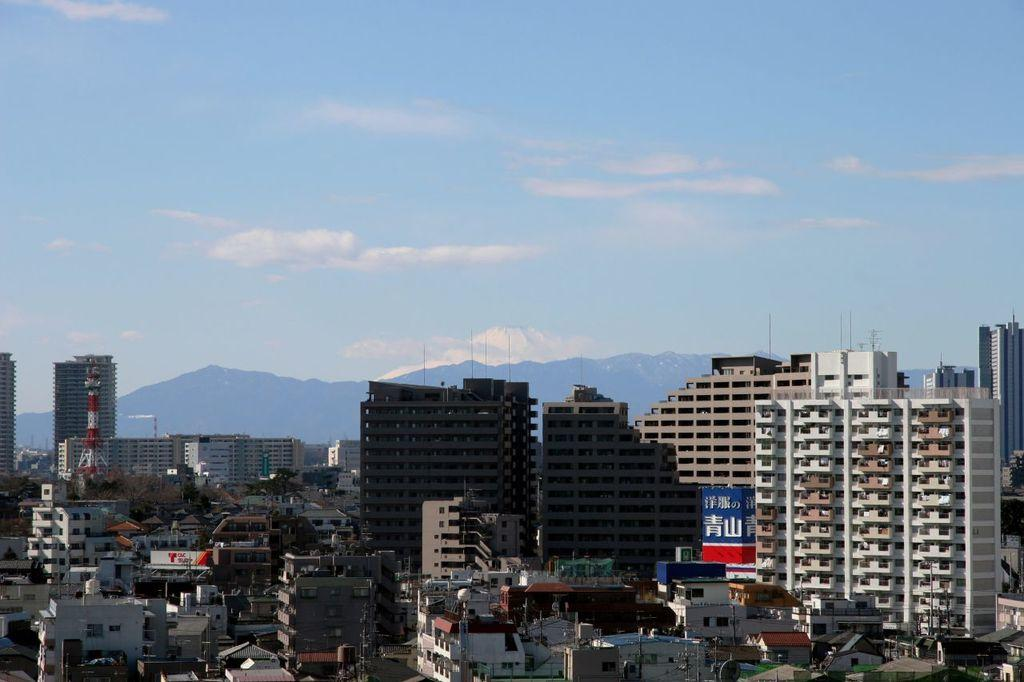What type of structures are present in the image? There are buildings in the image. What colors are the buildings? The buildings are in cream, white, and brown colors. What can be seen in the background of the image? There are mountains in the background of the image. What is the color of the sky in the image? The sky is blue and white in color. Can you tell me how many fans are visible in the image? There are no fans present in the image. What type of dress is the mountain wearing in the image? There is no dress present in the image, as mountains are not capable of wearing clothing. 